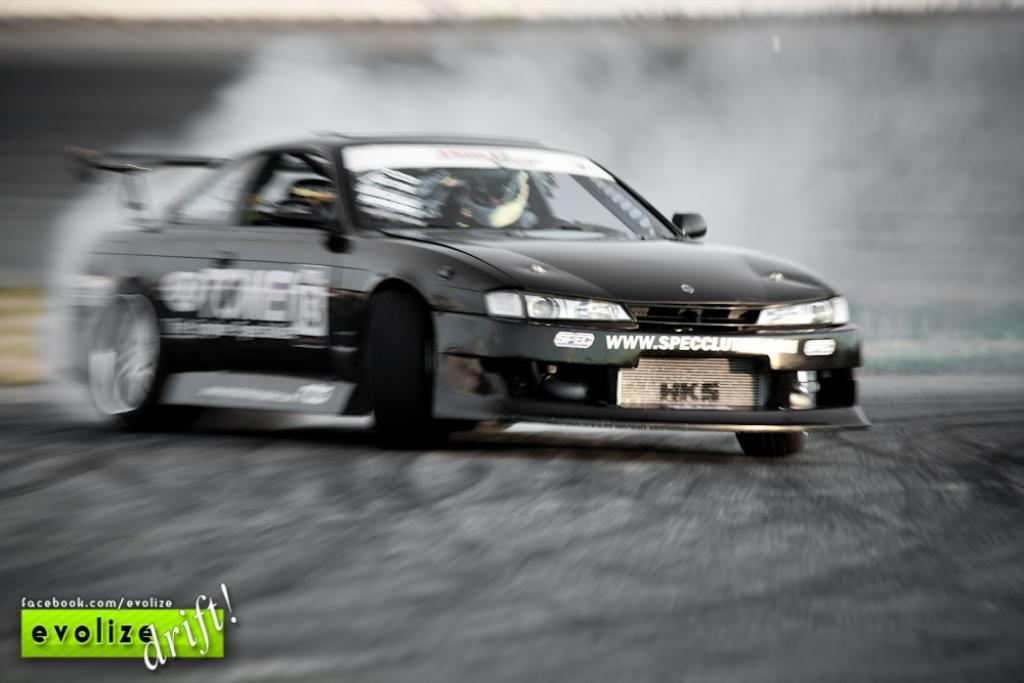What is the overall quality of the image? The picture is blurred. What can be seen in the image despite the blurriness? There is a car in the image. What is the color of the car? The car is black in color. Are there any markings or text on the car? Yes, there are things written on the car. Can you touch the curve on the car in the image? It is not possible to touch the image or any elements within it, as it is a digital representation. Additionally, there is no mention of a curve on the car in the provided facts. 